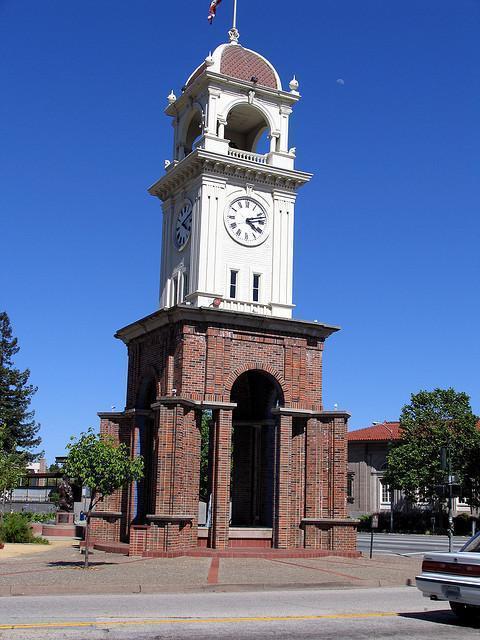What can someone know by looking at the white tower?
From the following four choices, select the correct answer to address the question.
Options: Date, time, year, month. Time. 